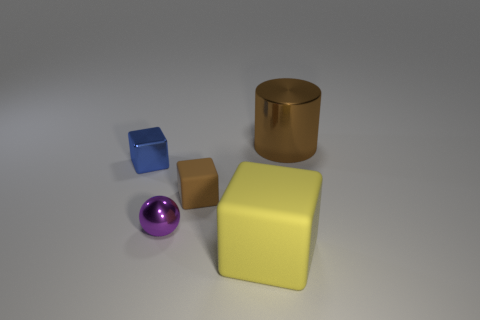There is another large thing that is the same shape as the blue shiny thing; what is its color?
Your answer should be compact. Yellow. How many tiny matte things are the same color as the metallic cylinder?
Ensure brevity in your answer.  1. What is the color of the big thing that is on the left side of the large object that is behind the yellow rubber thing that is in front of the shiny ball?
Offer a terse response. Yellow. Do the tiny blue block and the big yellow object have the same material?
Keep it short and to the point. No. Is the shape of the yellow thing the same as the brown rubber thing?
Offer a terse response. Yes. Are there an equal number of spheres that are right of the big yellow block and cubes behind the purple sphere?
Your response must be concise. No. The tiny sphere that is made of the same material as the cylinder is what color?
Keep it short and to the point. Purple. How many big objects are made of the same material as the brown cylinder?
Your response must be concise. 0. There is a big object behind the small brown rubber object; is its color the same as the small matte object?
Offer a very short reply. Yes. What number of big metallic objects are the same shape as the small rubber thing?
Your answer should be very brief. 0. 